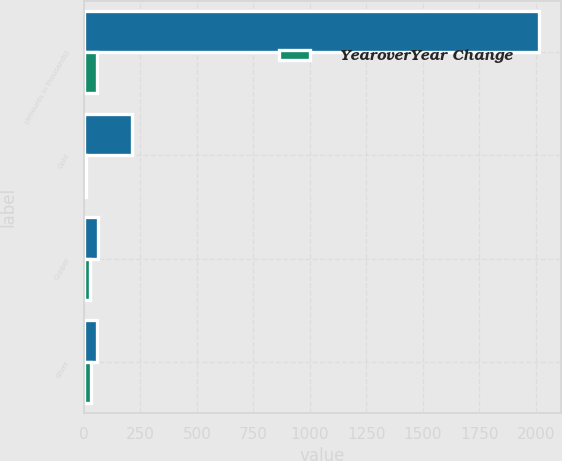<chart> <loc_0><loc_0><loc_500><loc_500><stacked_bar_chart><ecel><fcel>(amounts in thousands)<fcel>Gold<fcel>Copper<fcel>Silver<nl><fcel>nan<fcel>2012<fcel>212<fcel>64<fcel>60<nl><fcel>YearoverYear Change<fcel>60<fcel>11<fcel>29<fcel>31<nl></chart> 